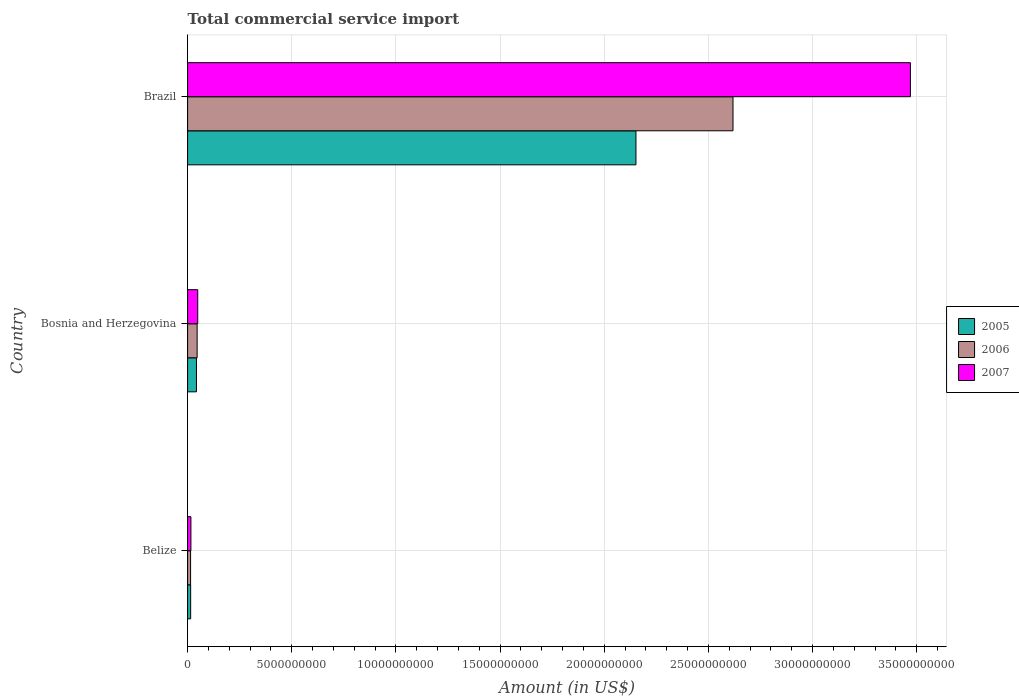How many groups of bars are there?
Provide a succinct answer. 3. Are the number of bars per tick equal to the number of legend labels?
Provide a short and direct response. Yes. How many bars are there on the 3rd tick from the top?
Offer a very short reply. 3. How many bars are there on the 1st tick from the bottom?
Ensure brevity in your answer.  3. What is the total commercial service import in 2005 in Bosnia and Herzegovina?
Offer a terse response. 4.25e+08. Across all countries, what is the maximum total commercial service import in 2005?
Offer a very short reply. 2.15e+1. Across all countries, what is the minimum total commercial service import in 2005?
Provide a succinct answer. 1.47e+08. In which country was the total commercial service import in 2006 maximum?
Make the answer very short. Brazil. In which country was the total commercial service import in 2007 minimum?
Provide a succinct answer. Belize. What is the total total commercial service import in 2007 in the graph?
Your response must be concise. 3.53e+1. What is the difference between the total commercial service import in 2005 in Belize and that in Brazil?
Offer a terse response. -2.14e+1. What is the difference between the total commercial service import in 2007 in Belize and the total commercial service import in 2006 in Brazil?
Your answer should be very brief. -2.60e+1. What is the average total commercial service import in 2005 per country?
Make the answer very short. 7.37e+09. What is the difference between the total commercial service import in 2005 and total commercial service import in 2006 in Bosnia and Herzegovina?
Ensure brevity in your answer.  -3.32e+07. In how many countries, is the total commercial service import in 2006 greater than 22000000000 US$?
Provide a succinct answer. 1. What is the ratio of the total commercial service import in 2007 in Belize to that in Brazil?
Keep it short and to the point. 0. What is the difference between the highest and the second highest total commercial service import in 2005?
Ensure brevity in your answer.  2.11e+1. What is the difference between the highest and the lowest total commercial service import in 2007?
Offer a very short reply. 3.45e+1. What does the 3rd bar from the top in Belize represents?
Provide a short and direct response. 2005. Is it the case that in every country, the sum of the total commercial service import in 2006 and total commercial service import in 2007 is greater than the total commercial service import in 2005?
Your answer should be compact. Yes. What is the difference between two consecutive major ticks on the X-axis?
Provide a succinct answer. 5.00e+09. Are the values on the major ticks of X-axis written in scientific E-notation?
Provide a short and direct response. No. Does the graph contain grids?
Offer a terse response. Yes. Where does the legend appear in the graph?
Keep it short and to the point. Center right. How many legend labels are there?
Your response must be concise. 3. What is the title of the graph?
Your answer should be very brief. Total commercial service import. What is the Amount (in US$) of 2005 in Belize?
Offer a very short reply. 1.47e+08. What is the Amount (in US$) in 2006 in Belize?
Make the answer very short. 1.43e+08. What is the Amount (in US$) in 2007 in Belize?
Keep it short and to the point. 1.59e+08. What is the Amount (in US$) of 2005 in Bosnia and Herzegovina?
Your answer should be very brief. 4.25e+08. What is the Amount (in US$) of 2006 in Bosnia and Herzegovina?
Keep it short and to the point. 4.58e+08. What is the Amount (in US$) of 2007 in Bosnia and Herzegovina?
Keep it short and to the point. 4.87e+08. What is the Amount (in US$) in 2005 in Brazil?
Ensure brevity in your answer.  2.15e+1. What is the Amount (in US$) in 2006 in Brazil?
Your response must be concise. 2.62e+1. What is the Amount (in US$) in 2007 in Brazil?
Make the answer very short. 3.47e+1. Across all countries, what is the maximum Amount (in US$) in 2005?
Your response must be concise. 2.15e+1. Across all countries, what is the maximum Amount (in US$) in 2006?
Make the answer very short. 2.62e+1. Across all countries, what is the maximum Amount (in US$) of 2007?
Give a very brief answer. 3.47e+1. Across all countries, what is the minimum Amount (in US$) of 2005?
Your response must be concise. 1.47e+08. Across all countries, what is the minimum Amount (in US$) in 2006?
Keep it short and to the point. 1.43e+08. Across all countries, what is the minimum Amount (in US$) of 2007?
Provide a succinct answer. 1.59e+08. What is the total Amount (in US$) of 2005 in the graph?
Keep it short and to the point. 2.21e+1. What is the total Amount (in US$) of 2006 in the graph?
Give a very brief answer. 2.68e+1. What is the total Amount (in US$) of 2007 in the graph?
Offer a terse response. 3.53e+1. What is the difference between the Amount (in US$) of 2005 in Belize and that in Bosnia and Herzegovina?
Offer a very short reply. -2.78e+08. What is the difference between the Amount (in US$) in 2006 in Belize and that in Bosnia and Herzegovina?
Give a very brief answer. -3.15e+08. What is the difference between the Amount (in US$) in 2007 in Belize and that in Bosnia and Herzegovina?
Provide a short and direct response. -3.28e+08. What is the difference between the Amount (in US$) in 2005 in Belize and that in Brazil?
Your response must be concise. -2.14e+1. What is the difference between the Amount (in US$) in 2006 in Belize and that in Brazil?
Provide a succinct answer. -2.60e+1. What is the difference between the Amount (in US$) in 2007 in Belize and that in Brazil?
Give a very brief answer. -3.45e+1. What is the difference between the Amount (in US$) in 2005 in Bosnia and Herzegovina and that in Brazil?
Ensure brevity in your answer.  -2.11e+1. What is the difference between the Amount (in US$) of 2006 in Bosnia and Herzegovina and that in Brazil?
Provide a succinct answer. -2.57e+1. What is the difference between the Amount (in US$) of 2007 in Bosnia and Herzegovina and that in Brazil?
Give a very brief answer. -3.42e+1. What is the difference between the Amount (in US$) in 2005 in Belize and the Amount (in US$) in 2006 in Bosnia and Herzegovina?
Offer a very short reply. -3.11e+08. What is the difference between the Amount (in US$) of 2005 in Belize and the Amount (in US$) of 2007 in Bosnia and Herzegovina?
Give a very brief answer. -3.39e+08. What is the difference between the Amount (in US$) in 2006 in Belize and the Amount (in US$) in 2007 in Bosnia and Herzegovina?
Give a very brief answer. -3.43e+08. What is the difference between the Amount (in US$) of 2005 in Belize and the Amount (in US$) of 2006 in Brazil?
Give a very brief answer. -2.60e+1. What is the difference between the Amount (in US$) of 2005 in Belize and the Amount (in US$) of 2007 in Brazil?
Make the answer very short. -3.46e+1. What is the difference between the Amount (in US$) in 2006 in Belize and the Amount (in US$) in 2007 in Brazil?
Your answer should be compact. -3.46e+1. What is the difference between the Amount (in US$) of 2005 in Bosnia and Herzegovina and the Amount (in US$) of 2006 in Brazil?
Provide a short and direct response. -2.58e+1. What is the difference between the Amount (in US$) in 2005 in Bosnia and Herzegovina and the Amount (in US$) in 2007 in Brazil?
Your answer should be very brief. -3.43e+1. What is the difference between the Amount (in US$) of 2006 in Bosnia and Herzegovina and the Amount (in US$) of 2007 in Brazil?
Your answer should be compact. -3.42e+1. What is the average Amount (in US$) of 2005 per country?
Give a very brief answer. 7.37e+09. What is the average Amount (in US$) in 2006 per country?
Your answer should be compact. 8.93e+09. What is the average Amount (in US$) in 2007 per country?
Offer a terse response. 1.18e+1. What is the difference between the Amount (in US$) of 2005 and Amount (in US$) of 2006 in Belize?
Your answer should be compact. 3.89e+06. What is the difference between the Amount (in US$) of 2005 and Amount (in US$) of 2007 in Belize?
Provide a short and direct response. -1.18e+07. What is the difference between the Amount (in US$) of 2006 and Amount (in US$) of 2007 in Belize?
Your answer should be very brief. -1.57e+07. What is the difference between the Amount (in US$) in 2005 and Amount (in US$) in 2006 in Bosnia and Herzegovina?
Your answer should be compact. -3.32e+07. What is the difference between the Amount (in US$) of 2005 and Amount (in US$) of 2007 in Bosnia and Herzegovina?
Your answer should be very brief. -6.18e+07. What is the difference between the Amount (in US$) in 2006 and Amount (in US$) in 2007 in Bosnia and Herzegovina?
Provide a short and direct response. -2.86e+07. What is the difference between the Amount (in US$) of 2005 and Amount (in US$) of 2006 in Brazil?
Your response must be concise. -4.66e+09. What is the difference between the Amount (in US$) in 2005 and Amount (in US$) in 2007 in Brazil?
Make the answer very short. -1.32e+1. What is the difference between the Amount (in US$) of 2006 and Amount (in US$) of 2007 in Brazil?
Your answer should be compact. -8.52e+09. What is the ratio of the Amount (in US$) of 2005 in Belize to that in Bosnia and Herzegovina?
Your response must be concise. 0.35. What is the ratio of the Amount (in US$) of 2006 in Belize to that in Bosnia and Herzegovina?
Give a very brief answer. 0.31. What is the ratio of the Amount (in US$) of 2007 in Belize to that in Bosnia and Herzegovina?
Provide a succinct answer. 0.33. What is the ratio of the Amount (in US$) in 2005 in Belize to that in Brazil?
Ensure brevity in your answer.  0.01. What is the ratio of the Amount (in US$) of 2006 in Belize to that in Brazil?
Provide a short and direct response. 0.01. What is the ratio of the Amount (in US$) in 2007 in Belize to that in Brazil?
Your answer should be compact. 0. What is the ratio of the Amount (in US$) of 2005 in Bosnia and Herzegovina to that in Brazil?
Keep it short and to the point. 0.02. What is the ratio of the Amount (in US$) of 2006 in Bosnia and Herzegovina to that in Brazil?
Your answer should be compact. 0.02. What is the ratio of the Amount (in US$) of 2007 in Bosnia and Herzegovina to that in Brazil?
Offer a very short reply. 0.01. What is the difference between the highest and the second highest Amount (in US$) in 2005?
Make the answer very short. 2.11e+1. What is the difference between the highest and the second highest Amount (in US$) of 2006?
Offer a very short reply. 2.57e+1. What is the difference between the highest and the second highest Amount (in US$) of 2007?
Provide a short and direct response. 3.42e+1. What is the difference between the highest and the lowest Amount (in US$) in 2005?
Provide a short and direct response. 2.14e+1. What is the difference between the highest and the lowest Amount (in US$) in 2006?
Provide a succinct answer. 2.60e+1. What is the difference between the highest and the lowest Amount (in US$) of 2007?
Your response must be concise. 3.45e+1. 